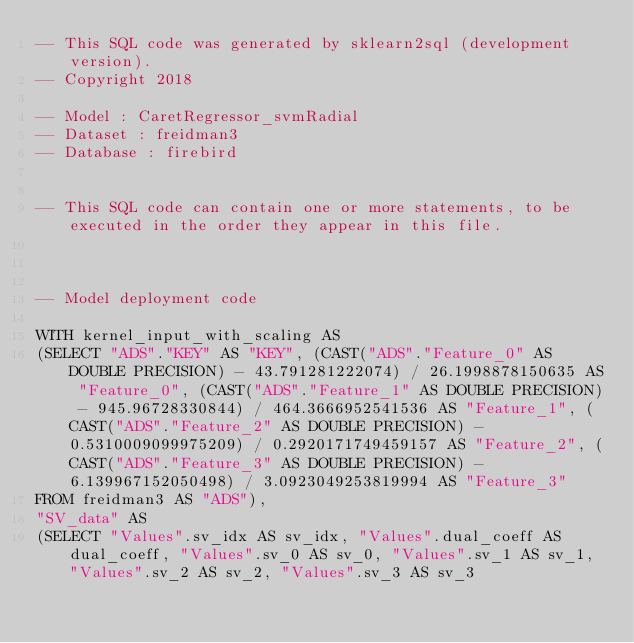<code> <loc_0><loc_0><loc_500><loc_500><_SQL_>-- This SQL code was generated by sklearn2sql (development version).
-- Copyright 2018

-- Model : CaretRegressor_svmRadial
-- Dataset : freidman3
-- Database : firebird


-- This SQL code can contain one or more statements, to be executed in the order they appear in this file.



-- Model deployment code

WITH kernel_input_with_scaling AS 
(SELECT "ADS"."KEY" AS "KEY", (CAST("ADS"."Feature_0" AS DOUBLE PRECISION) - 43.791281222074) / 26.1998878150635 AS "Feature_0", (CAST("ADS"."Feature_1" AS DOUBLE PRECISION) - 945.96728330844) / 464.3666952541536 AS "Feature_1", (CAST("ADS"."Feature_2" AS DOUBLE PRECISION) - 0.5310009099975209) / 0.2920171749459157 AS "Feature_2", (CAST("ADS"."Feature_3" AS DOUBLE PRECISION) - 6.139967152050498) / 3.0923049253819994 AS "Feature_3" 
FROM freidman3 AS "ADS"), 
"SV_data" AS 
(SELECT "Values".sv_idx AS sv_idx, "Values".dual_coeff AS dual_coeff, "Values".sv_0 AS sv_0, "Values".sv_1 AS sv_1, "Values".sv_2 AS sv_2, "Values".sv_3 AS sv_3 </code> 